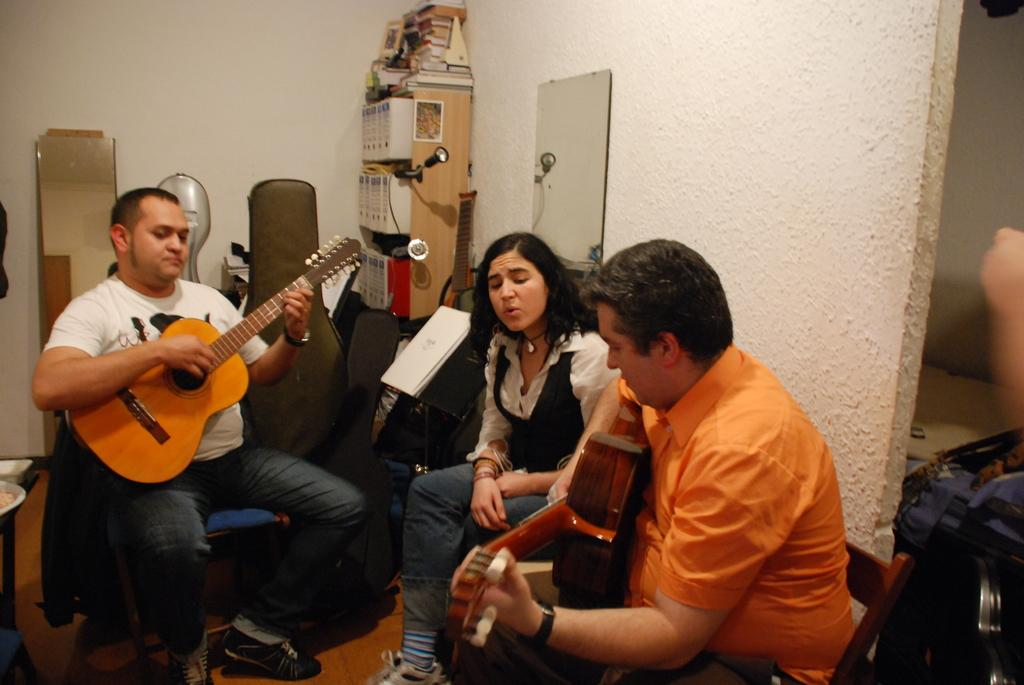How many people are in the image? There are three people in the image. What are the men doing in the image? The men are playing guitar. What is the woman doing in the image? The woman is singing. How high is the kite flying in the image? There is no kite present in the image. What is the distance between the two men in the image? The provided facts do not give information about the distance between the two men, only that they are playing guitar. 